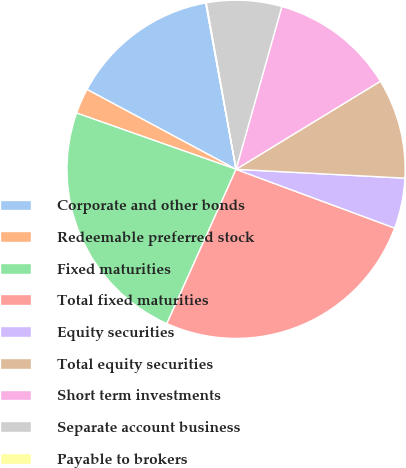Convert chart. <chart><loc_0><loc_0><loc_500><loc_500><pie_chart><fcel>Corporate and other bonds<fcel>Redeemable preferred stock<fcel>Fixed maturities<fcel>Total fixed maturities<fcel>Equity securities<fcel>Total equity securities<fcel>Short term investments<fcel>Separate account business<fcel>Payable to brokers<nl><fcel>14.29%<fcel>2.43%<fcel>23.69%<fcel>26.06%<fcel>4.81%<fcel>9.55%<fcel>11.92%<fcel>7.18%<fcel>0.06%<nl></chart> 